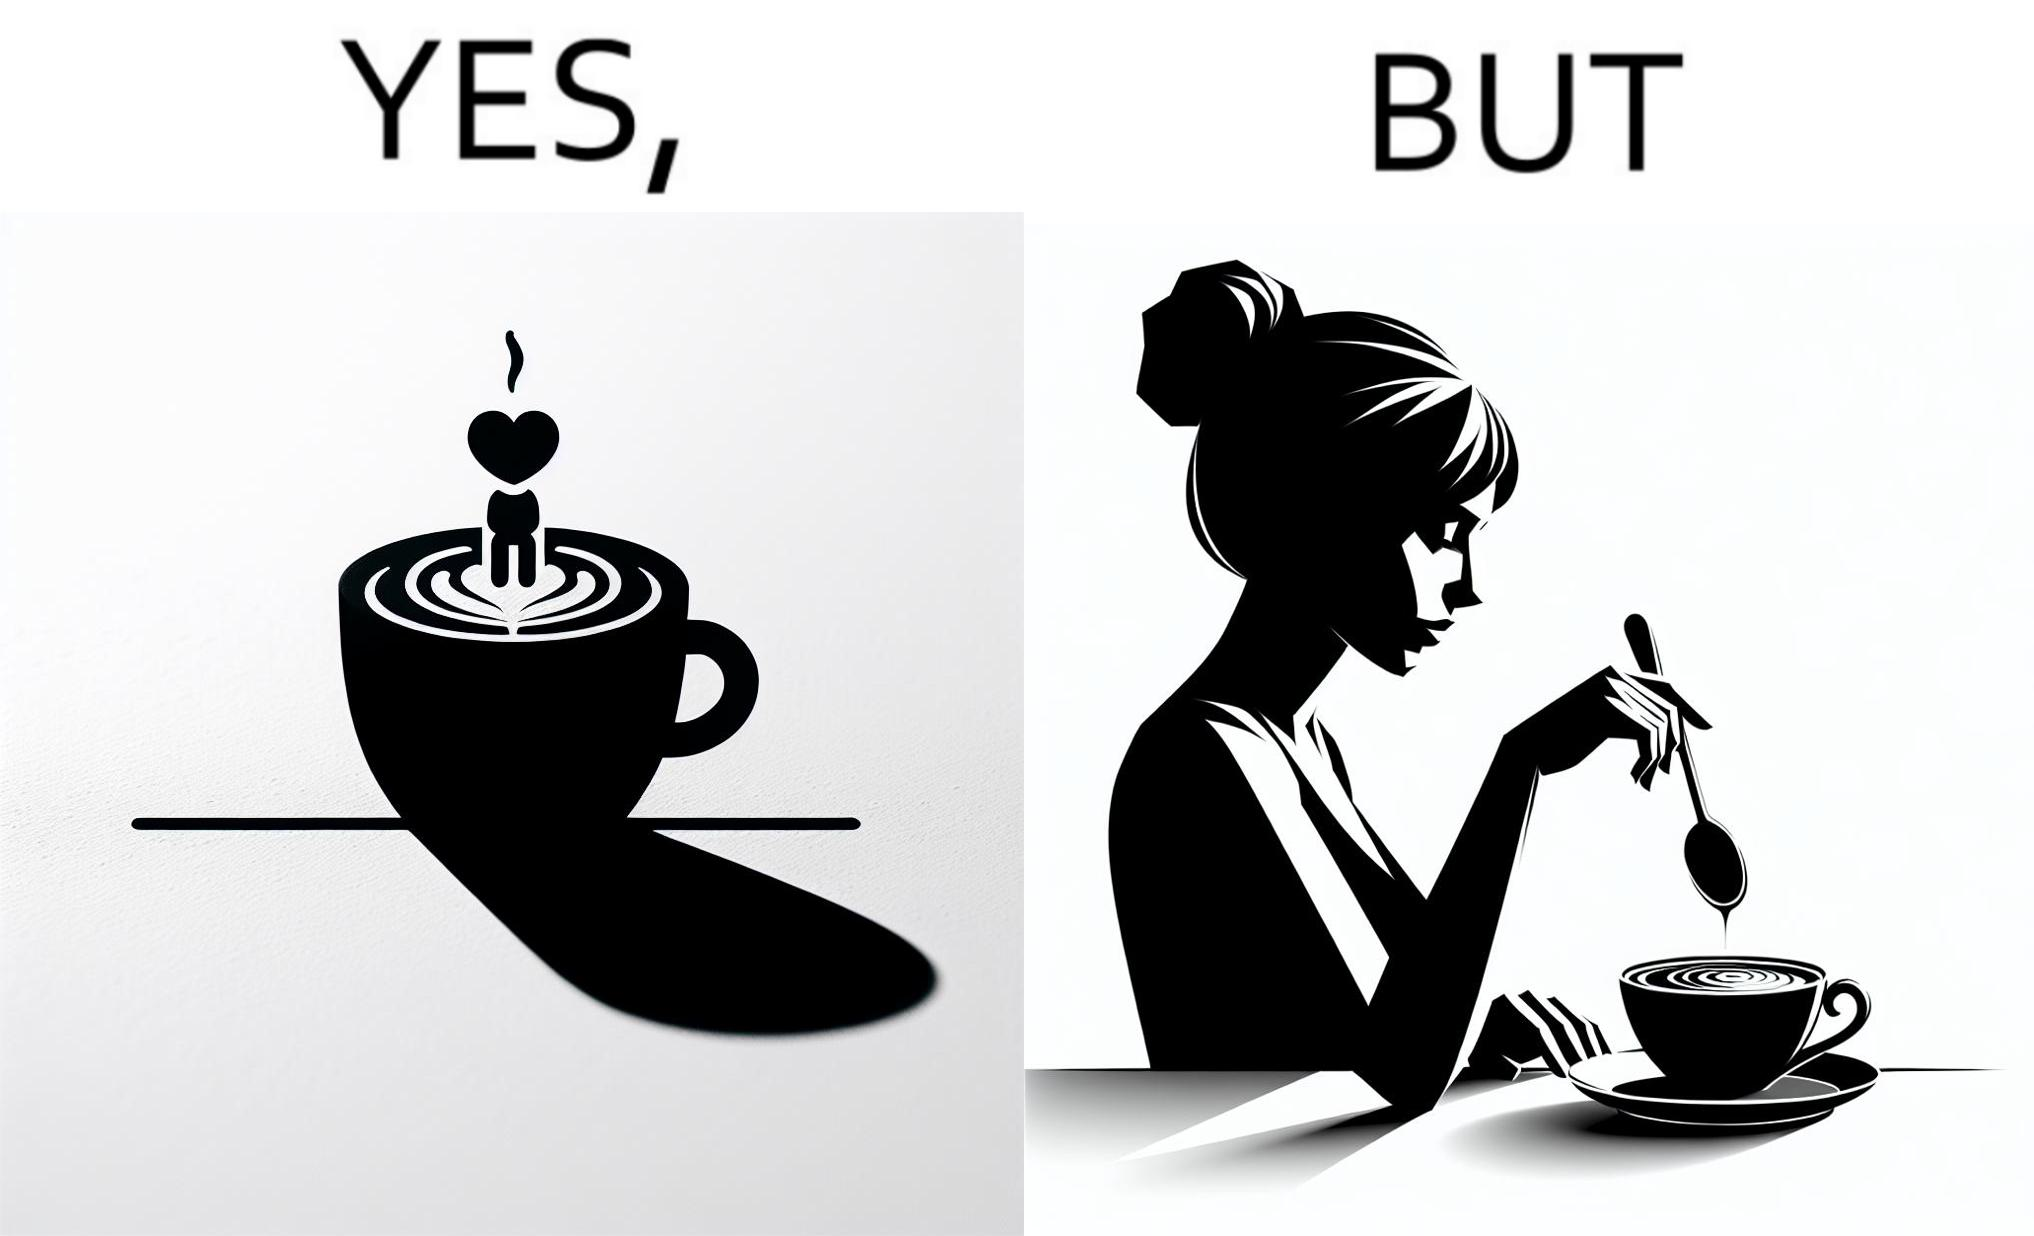Describe the satirical element in this image. The image is ironic, because even when the coffee maker create latte art to make coffee look attractive but it is there just for a short time after that it is vanished 